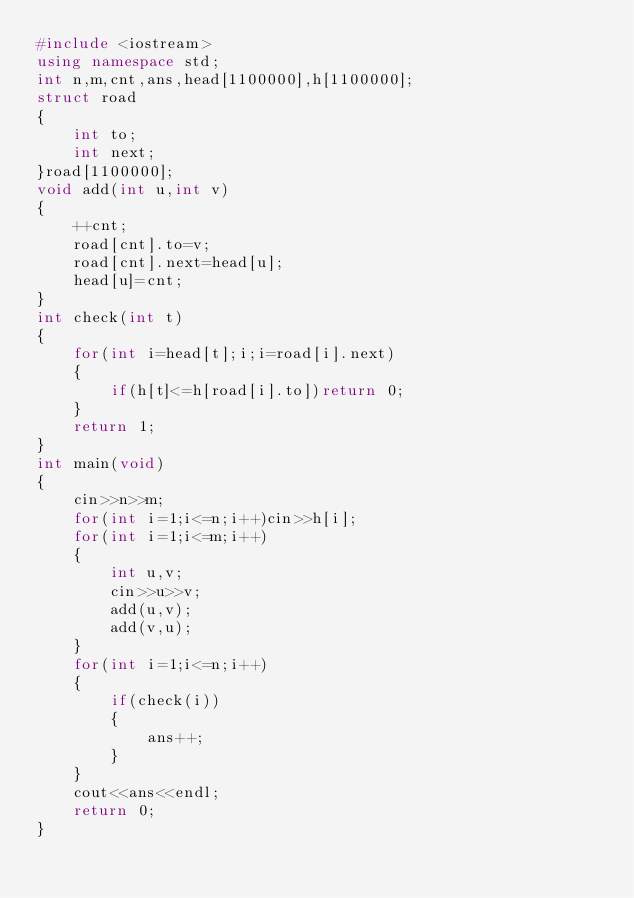<code> <loc_0><loc_0><loc_500><loc_500><_C++_>#include <iostream>
using namespace std;
int n,m,cnt,ans,head[1100000],h[1100000];
struct road
{
    int to;
    int next;
}road[1100000];
void add(int u,int v)
{
    ++cnt;
    road[cnt].to=v;
    road[cnt].next=head[u];
    head[u]=cnt;
}
int check(int t)
{
    for(int i=head[t];i;i=road[i].next)
    {
        if(h[t]<=h[road[i].to])return 0;
    }
    return 1;
}
int main(void)
{
    cin>>n>>m;
    for(int i=1;i<=n;i++)cin>>h[i];
    for(int i=1;i<=m;i++)
    {
        int u,v;
        cin>>u>>v;
        add(u,v);
        add(v,u);
    }
    for(int i=1;i<=n;i++)
    {
        if(check(i))
        {
            ans++;
        }
    }
    cout<<ans<<endl;
    return 0;
}</code> 